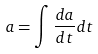<formula> <loc_0><loc_0><loc_500><loc_500>a = \int \frac { d a } { d t } d t</formula> 